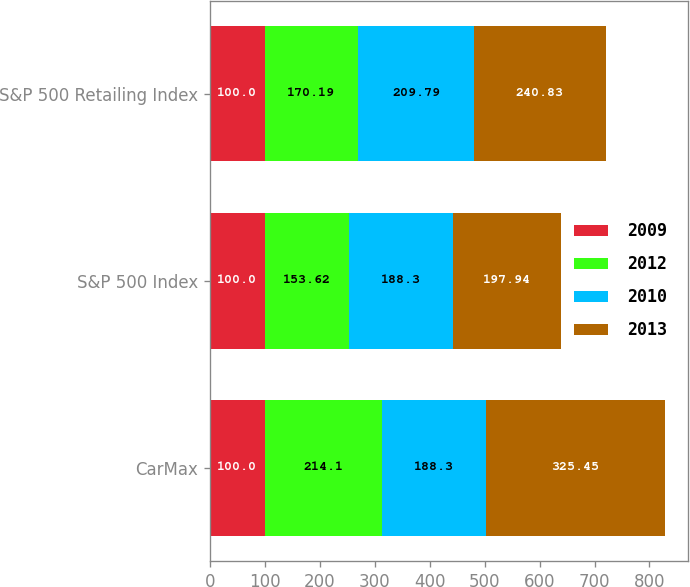Convert chart. <chart><loc_0><loc_0><loc_500><loc_500><stacked_bar_chart><ecel><fcel>CarMax<fcel>S&P 500 Index<fcel>S&P 500 Retailing Index<nl><fcel>2009<fcel>100<fcel>100<fcel>100<nl><fcel>2012<fcel>214.1<fcel>153.62<fcel>170.19<nl><fcel>2010<fcel>188.3<fcel>188.3<fcel>209.79<nl><fcel>2013<fcel>325.45<fcel>197.94<fcel>240.83<nl></chart> 